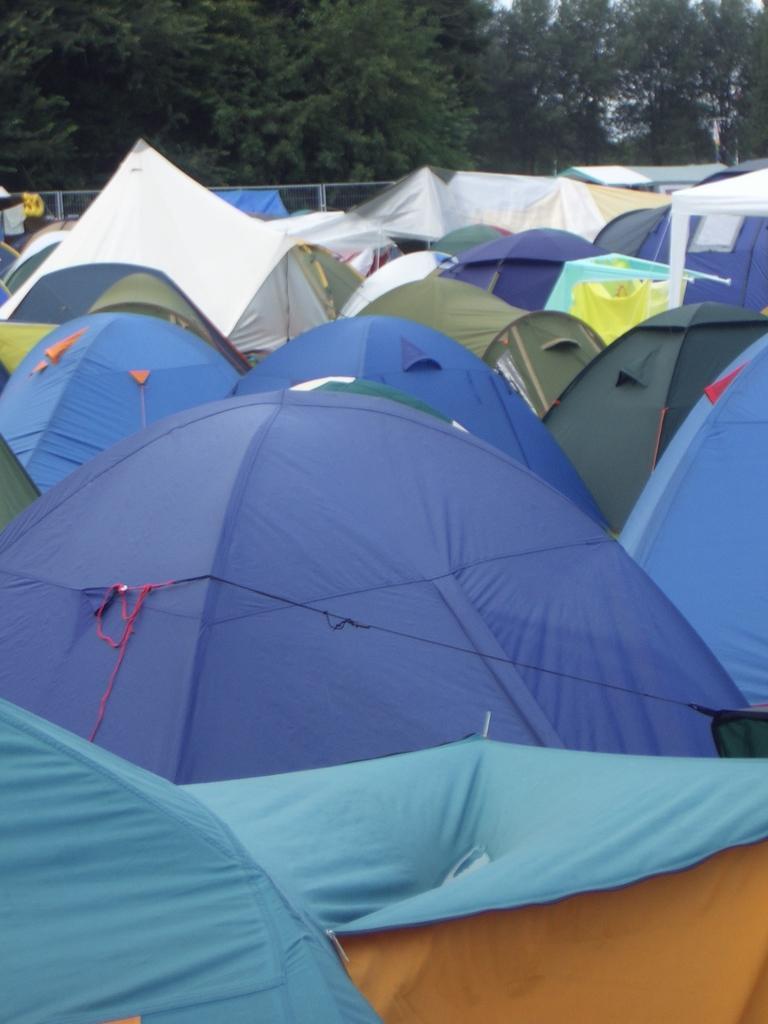How would you summarize this image in a sentence or two? In this image there are tents which are green, blue and white in colour. In the background there are trees. 